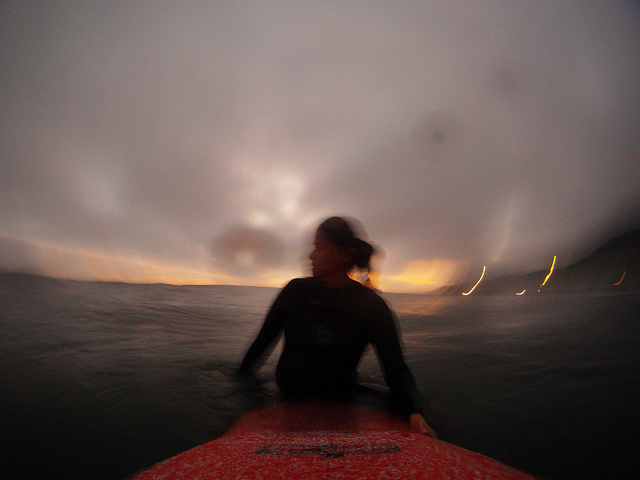Describe the setting and mood depicted in the image. The image captures a surreal, almost ethereal setting at dusk, where the fading light casts a soft glow on the horizon. The sky is overcast, hinting at a stormy or unsettled weather pattern, which in turn lends a dramatic and moody atmosphere to the scene, perfectly aligning with the adventurous spirit of the surfer. 